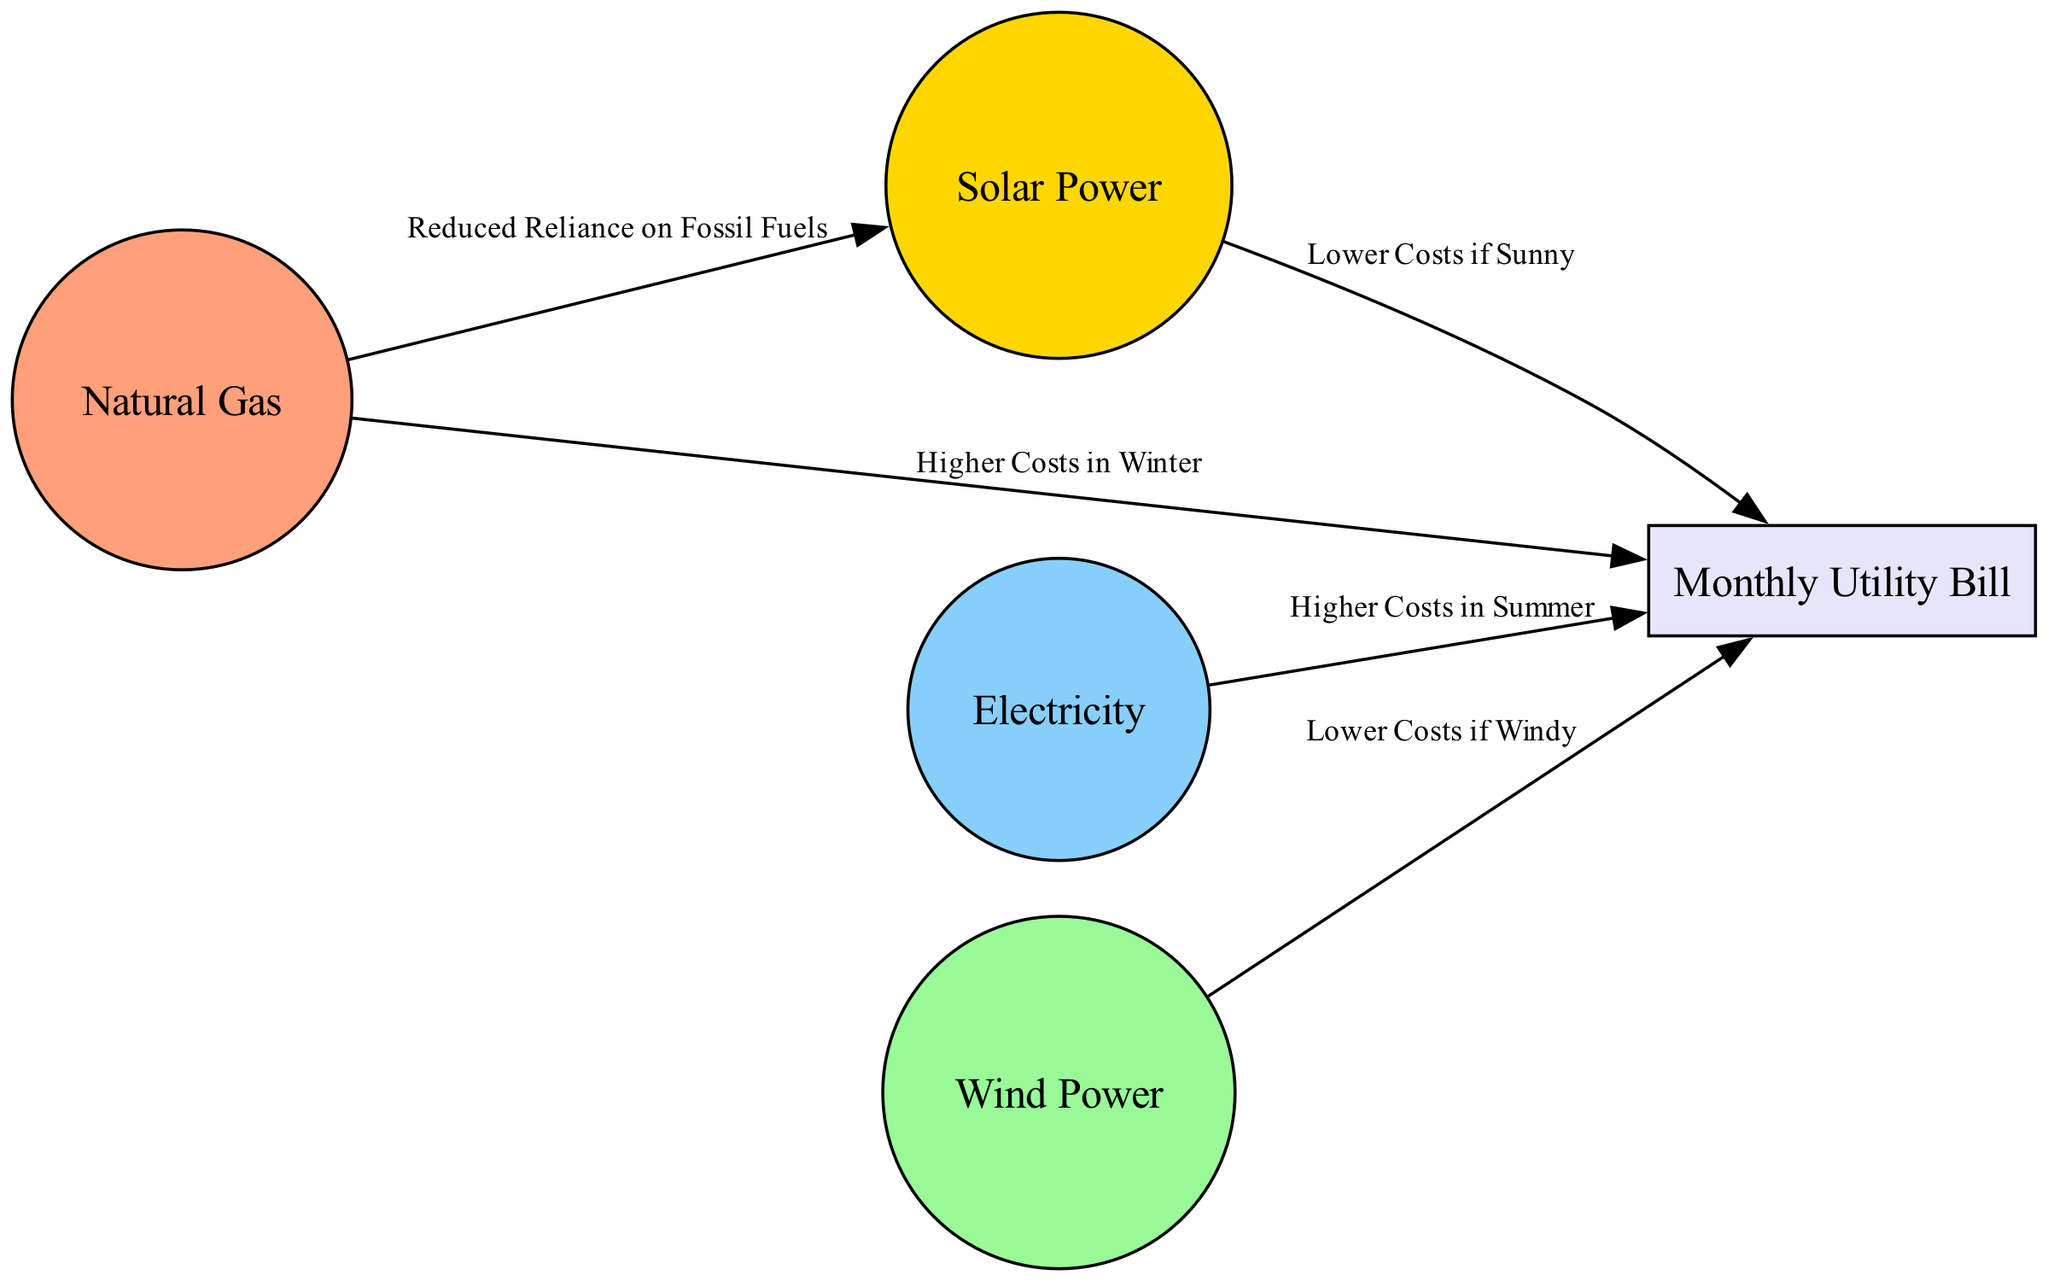What is the effect of natural gas on monthly utility bills? The diagram indicates that natural gas is associated with "Higher Costs in Winter" as it connects directly to the monthly utility bill node with this label.
Answer: Higher Costs in Winter How many energy sources are represented in the diagram? There are four energy sources listed in the nodes: natural gas, electricity, solar power, and wind power. By counting these, I determine that the total is four.
Answer: Four What does solar power do to monthly utility bills? The diagram shows that solar power contributes to "Lower Costs if Sunny" indicating a positive relationship with utility bills under certain conditions.
Answer: Lower Costs if Sunny What is the relationship between wind power and monthly utility bills? The connection is labeled as "Lower Costs if Windy," which means that wind power reduces the monthly utility bill when conditions are favorable.
Answer: Lower Costs if Windy Which energy source indicates reduced reliance on fossil fuels? From the diagram, the edge connecting natural gas to solar power is labeled "Reduced Reliance on Fossil Fuels," indicating this benefit.
Answer: Reduced Reliance on Fossil Fuels 